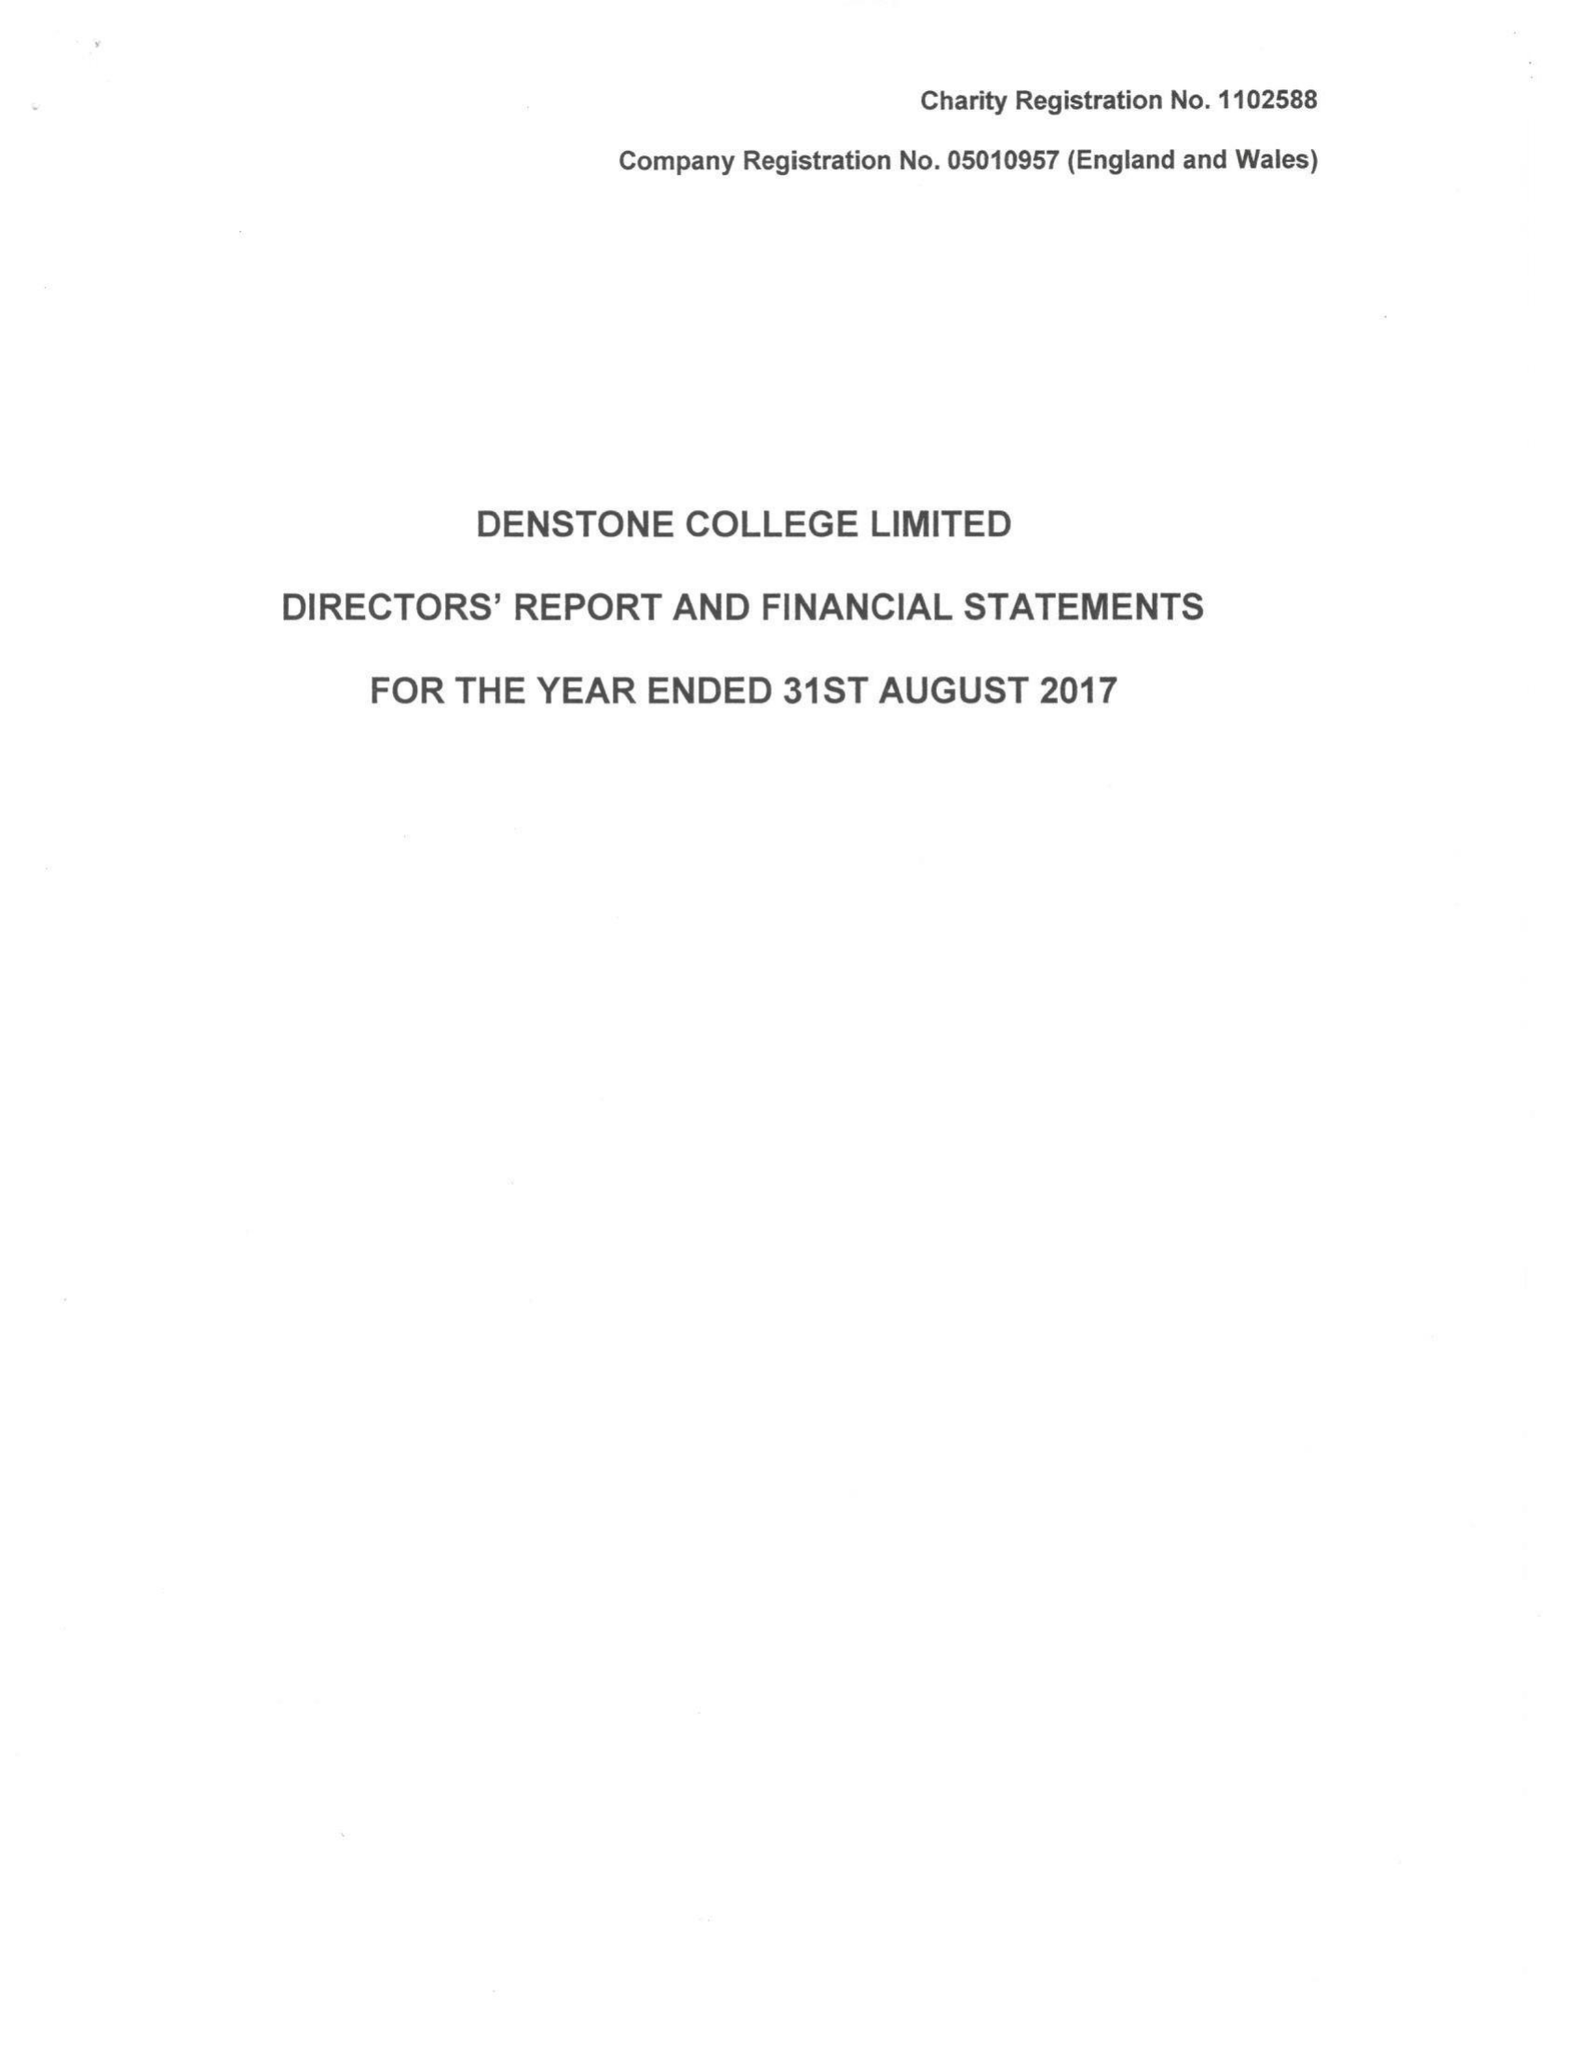What is the value for the report_date?
Answer the question using a single word or phrase. 2017-08-31 